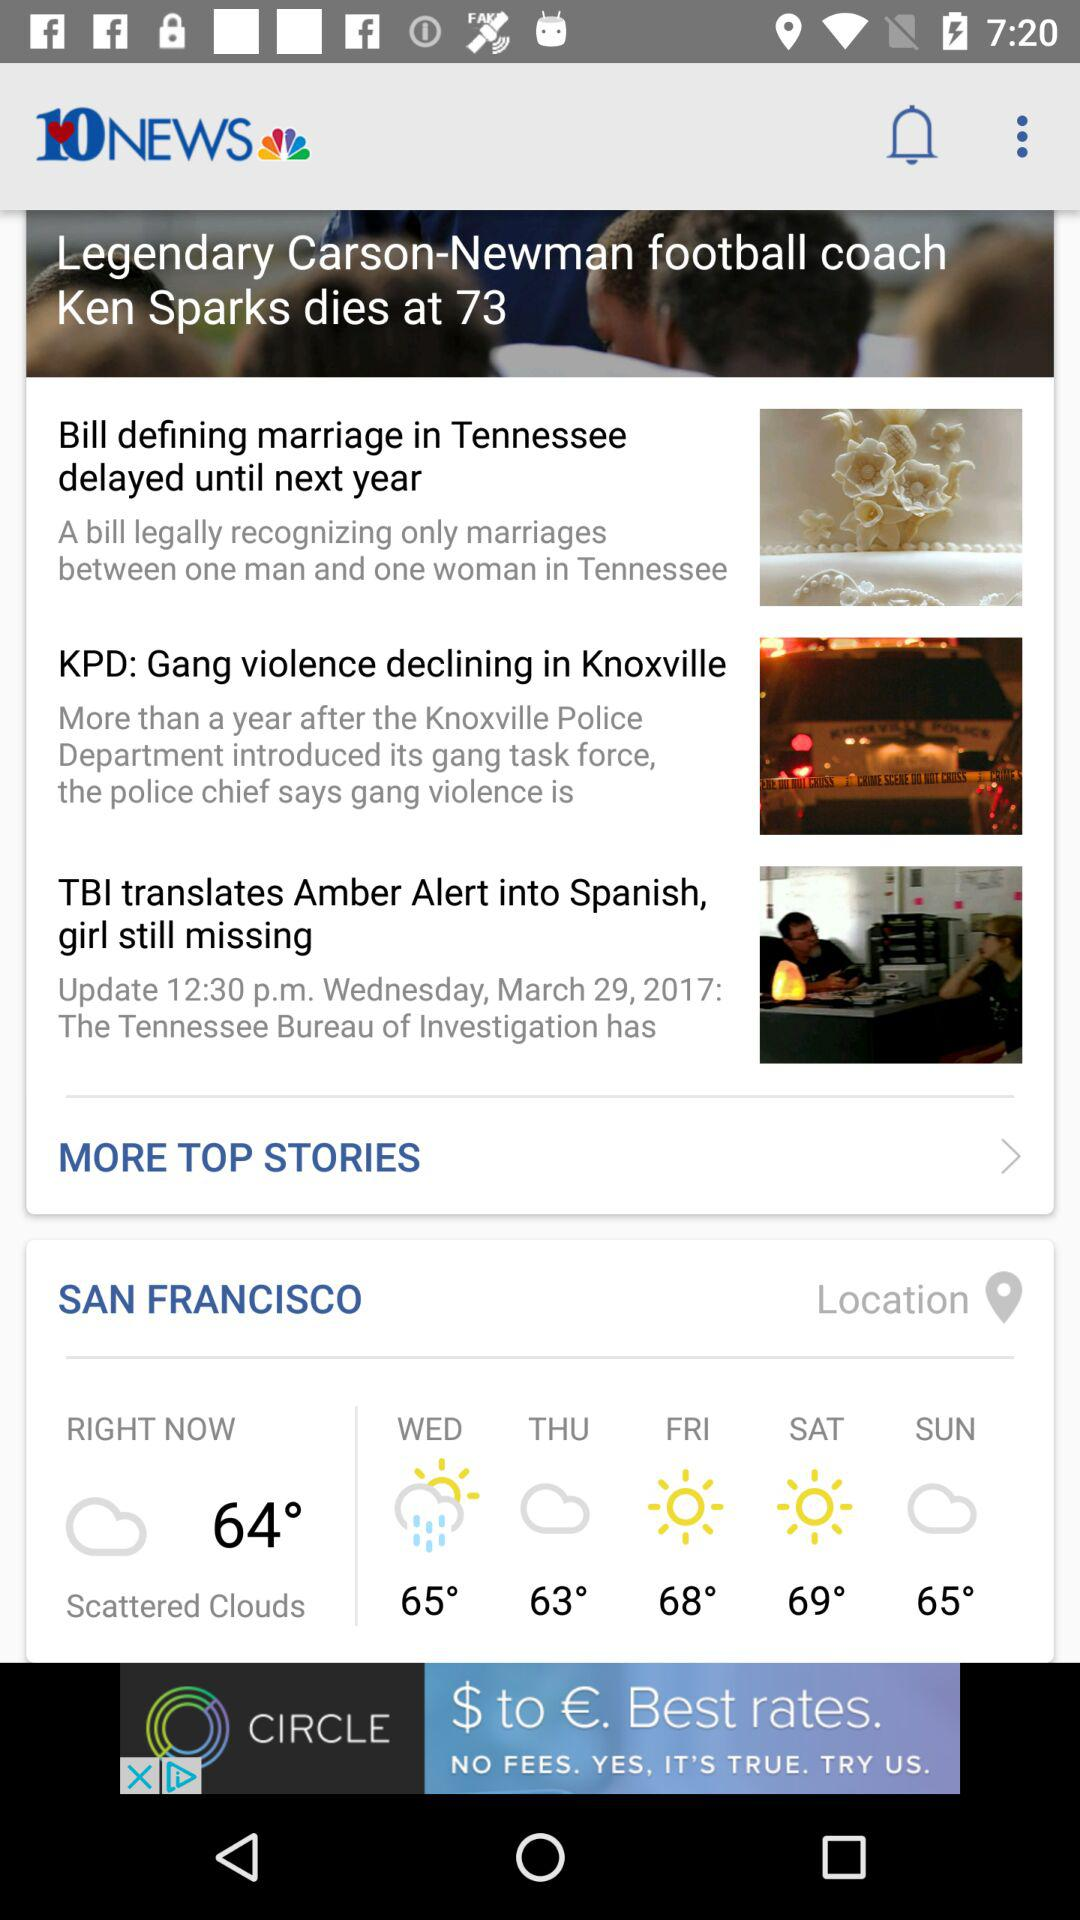What is the current temperature shown on the screen? The current temperature is 64°. 